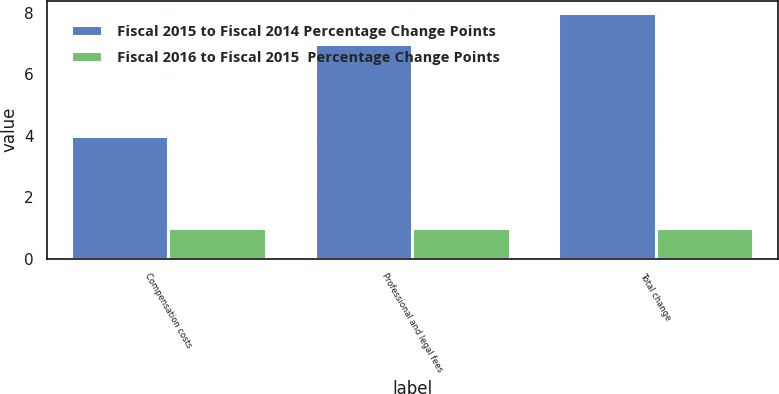Convert chart. <chart><loc_0><loc_0><loc_500><loc_500><stacked_bar_chart><ecel><fcel>Compensation costs<fcel>Professional and legal fees<fcel>Total change<nl><fcel>Fiscal 2015 to Fiscal 2014 Percentage Change Points<fcel>4<fcel>7<fcel>8<nl><fcel>Fiscal 2016 to Fiscal 2015  Percentage Change Points<fcel>1<fcel>1<fcel>1<nl></chart> 